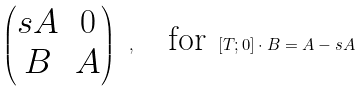Convert formula to latex. <formula><loc_0><loc_0><loc_500><loc_500>\begin{pmatrix} s A & 0 \\ B & A \end{pmatrix} \ , \quad \text {for} \ [ T ; 0 ] \cdot B = A - s A</formula> 